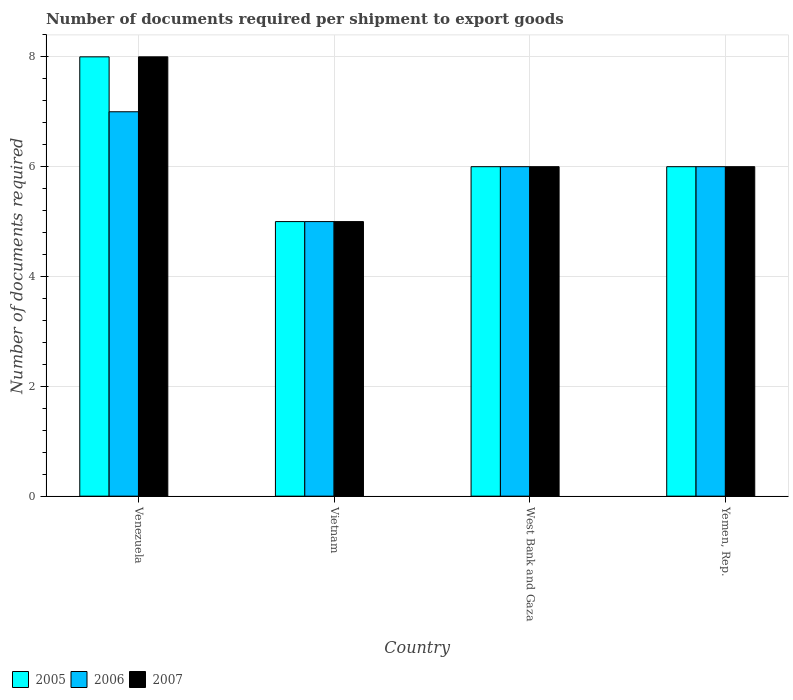How many bars are there on the 3rd tick from the left?
Provide a short and direct response. 3. What is the label of the 2nd group of bars from the left?
Give a very brief answer. Vietnam. Across all countries, what is the maximum number of documents required per shipment to export goods in 2005?
Offer a very short reply. 8. Across all countries, what is the minimum number of documents required per shipment to export goods in 2005?
Offer a terse response. 5. In which country was the number of documents required per shipment to export goods in 2006 maximum?
Your answer should be compact. Venezuela. In which country was the number of documents required per shipment to export goods in 2005 minimum?
Your answer should be compact. Vietnam. What is the total number of documents required per shipment to export goods in 2007 in the graph?
Offer a very short reply. 25. What is the difference between the number of documents required per shipment to export goods in 2006 in Vietnam and that in Yemen, Rep.?
Your response must be concise. -1. What is the difference between the number of documents required per shipment to export goods in 2006 in Yemen, Rep. and the number of documents required per shipment to export goods in 2005 in West Bank and Gaza?
Keep it short and to the point. 0. What is the average number of documents required per shipment to export goods in 2005 per country?
Ensure brevity in your answer.  6.25. In how many countries, is the number of documents required per shipment to export goods in 2007 greater than 5.6?
Ensure brevity in your answer.  3. What is the ratio of the number of documents required per shipment to export goods in 2007 in Vietnam to that in West Bank and Gaza?
Provide a succinct answer. 0.83. Is the number of documents required per shipment to export goods in 2006 in Vietnam less than that in West Bank and Gaza?
Provide a short and direct response. Yes. What is the difference between the highest and the second highest number of documents required per shipment to export goods in 2006?
Your response must be concise. -1. What is the difference between the highest and the lowest number of documents required per shipment to export goods in 2005?
Your answer should be compact. 3. What does the 2nd bar from the left in West Bank and Gaza represents?
Keep it short and to the point. 2006. What does the 1st bar from the right in Yemen, Rep. represents?
Provide a succinct answer. 2007. Is it the case that in every country, the sum of the number of documents required per shipment to export goods in 2006 and number of documents required per shipment to export goods in 2007 is greater than the number of documents required per shipment to export goods in 2005?
Ensure brevity in your answer.  Yes. How many bars are there?
Provide a succinct answer. 12. Are all the bars in the graph horizontal?
Keep it short and to the point. No. How many countries are there in the graph?
Your answer should be very brief. 4. Are the values on the major ticks of Y-axis written in scientific E-notation?
Offer a very short reply. No. Does the graph contain any zero values?
Ensure brevity in your answer.  No. How many legend labels are there?
Your answer should be very brief. 3. How are the legend labels stacked?
Ensure brevity in your answer.  Horizontal. What is the title of the graph?
Provide a succinct answer. Number of documents required per shipment to export goods. Does "2006" appear as one of the legend labels in the graph?
Make the answer very short. Yes. What is the label or title of the X-axis?
Give a very brief answer. Country. What is the label or title of the Y-axis?
Your response must be concise. Number of documents required. What is the Number of documents required in 2007 in Venezuela?
Ensure brevity in your answer.  8. What is the Number of documents required in 2006 in Vietnam?
Make the answer very short. 5. What is the Number of documents required of 2005 in Yemen, Rep.?
Your answer should be compact. 6. Across all countries, what is the maximum Number of documents required in 2006?
Your response must be concise. 7. Across all countries, what is the minimum Number of documents required of 2006?
Your answer should be very brief. 5. Across all countries, what is the minimum Number of documents required in 2007?
Ensure brevity in your answer.  5. What is the total Number of documents required of 2005 in the graph?
Your answer should be very brief. 25. What is the total Number of documents required in 2007 in the graph?
Keep it short and to the point. 25. What is the difference between the Number of documents required of 2006 in Venezuela and that in Vietnam?
Your answer should be compact. 2. What is the difference between the Number of documents required of 2007 in Venezuela and that in Vietnam?
Provide a short and direct response. 3. What is the difference between the Number of documents required of 2007 in Venezuela and that in West Bank and Gaza?
Give a very brief answer. 2. What is the difference between the Number of documents required of 2005 in Venezuela and that in Yemen, Rep.?
Keep it short and to the point. 2. What is the difference between the Number of documents required in 2006 in Venezuela and that in Yemen, Rep.?
Your answer should be compact. 1. What is the difference between the Number of documents required of 2007 in Venezuela and that in Yemen, Rep.?
Provide a short and direct response. 2. What is the difference between the Number of documents required in 2006 in Vietnam and that in West Bank and Gaza?
Keep it short and to the point. -1. What is the difference between the Number of documents required in 2007 in Vietnam and that in West Bank and Gaza?
Your response must be concise. -1. What is the difference between the Number of documents required in 2006 in Vietnam and that in Yemen, Rep.?
Provide a short and direct response. -1. What is the difference between the Number of documents required in 2007 in Vietnam and that in Yemen, Rep.?
Your answer should be compact. -1. What is the difference between the Number of documents required of 2005 in Venezuela and the Number of documents required of 2006 in Vietnam?
Provide a short and direct response. 3. What is the difference between the Number of documents required in 2005 in Venezuela and the Number of documents required in 2007 in Vietnam?
Provide a short and direct response. 3. What is the difference between the Number of documents required of 2006 in Venezuela and the Number of documents required of 2007 in Vietnam?
Keep it short and to the point. 2. What is the difference between the Number of documents required of 2005 in Venezuela and the Number of documents required of 2006 in West Bank and Gaza?
Keep it short and to the point. 2. What is the difference between the Number of documents required of 2005 in Vietnam and the Number of documents required of 2006 in West Bank and Gaza?
Make the answer very short. -1. What is the difference between the Number of documents required of 2005 in Vietnam and the Number of documents required of 2007 in West Bank and Gaza?
Ensure brevity in your answer.  -1. What is the difference between the Number of documents required in 2006 in Vietnam and the Number of documents required in 2007 in West Bank and Gaza?
Keep it short and to the point. -1. What is the difference between the Number of documents required in 2005 in Vietnam and the Number of documents required in 2006 in Yemen, Rep.?
Offer a terse response. -1. What is the difference between the Number of documents required in 2005 in Vietnam and the Number of documents required in 2007 in Yemen, Rep.?
Give a very brief answer. -1. What is the difference between the Number of documents required in 2005 in West Bank and Gaza and the Number of documents required in 2006 in Yemen, Rep.?
Provide a succinct answer. 0. What is the difference between the Number of documents required of 2006 in West Bank and Gaza and the Number of documents required of 2007 in Yemen, Rep.?
Give a very brief answer. 0. What is the average Number of documents required in 2005 per country?
Provide a succinct answer. 6.25. What is the average Number of documents required of 2006 per country?
Your answer should be very brief. 6. What is the average Number of documents required of 2007 per country?
Provide a short and direct response. 6.25. What is the difference between the Number of documents required in 2005 and Number of documents required in 2006 in Venezuela?
Provide a short and direct response. 1. What is the difference between the Number of documents required in 2005 and Number of documents required in 2007 in Venezuela?
Make the answer very short. 0. What is the difference between the Number of documents required of 2006 and Number of documents required of 2007 in Venezuela?
Offer a terse response. -1. What is the difference between the Number of documents required of 2005 and Number of documents required of 2006 in Vietnam?
Your answer should be compact. 0. What is the difference between the Number of documents required of 2005 and Number of documents required of 2007 in Vietnam?
Keep it short and to the point. 0. What is the difference between the Number of documents required in 2006 and Number of documents required in 2007 in Vietnam?
Provide a succinct answer. 0. What is the difference between the Number of documents required in 2005 and Number of documents required in 2007 in West Bank and Gaza?
Offer a terse response. 0. What is the ratio of the Number of documents required of 2006 in Venezuela to that in Vietnam?
Your answer should be very brief. 1.4. What is the ratio of the Number of documents required in 2007 in Venezuela to that in Vietnam?
Your answer should be compact. 1.6. What is the ratio of the Number of documents required of 2005 in Venezuela to that in West Bank and Gaza?
Offer a terse response. 1.33. What is the ratio of the Number of documents required of 2006 in Venezuela to that in West Bank and Gaza?
Ensure brevity in your answer.  1.17. What is the ratio of the Number of documents required in 2007 in Venezuela to that in West Bank and Gaza?
Keep it short and to the point. 1.33. What is the ratio of the Number of documents required in 2005 in Venezuela to that in Yemen, Rep.?
Offer a terse response. 1.33. What is the ratio of the Number of documents required in 2006 in Venezuela to that in Yemen, Rep.?
Provide a short and direct response. 1.17. What is the ratio of the Number of documents required of 2007 in Venezuela to that in Yemen, Rep.?
Offer a terse response. 1.33. What is the ratio of the Number of documents required of 2005 in Vietnam to that in West Bank and Gaza?
Your answer should be very brief. 0.83. What is the ratio of the Number of documents required of 2007 in Vietnam to that in West Bank and Gaza?
Offer a terse response. 0.83. What is the ratio of the Number of documents required of 2007 in Vietnam to that in Yemen, Rep.?
Offer a very short reply. 0.83. What is the ratio of the Number of documents required of 2005 in West Bank and Gaza to that in Yemen, Rep.?
Offer a very short reply. 1. What is the ratio of the Number of documents required of 2007 in West Bank and Gaza to that in Yemen, Rep.?
Your response must be concise. 1. What is the difference between the highest and the second highest Number of documents required of 2006?
Provide a short and direct response. 1. What is the difference between the highest and the second highest Number of documents required of 2007?
Ensure brevity in your answer.  2. What is the difference between the highest and the lowest Number of documents required of 2005?
Offer a very short reply. 3. What is the difference between the highest and the lowest Number of documents required in 2006?
Provide a short and direct response. 2. What is the difference between the highest and the lowest Number of documents required of 2007?
Your response must be concise. 3. 